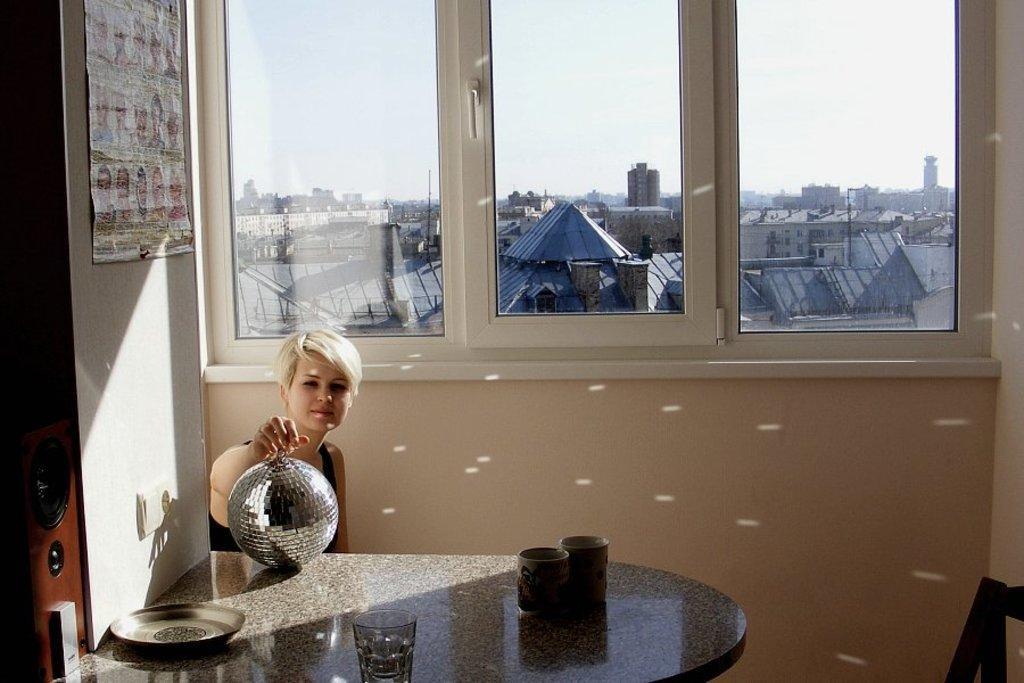Can you describe this image briefly? The picture is taken in a closed room in which one woman is sitting and holding a silver ball on the table and on the table there are cups and plate and behind her there are glass windows and outside the glass windows there are number of buildings and a sky and beside her there is wall with poster. 